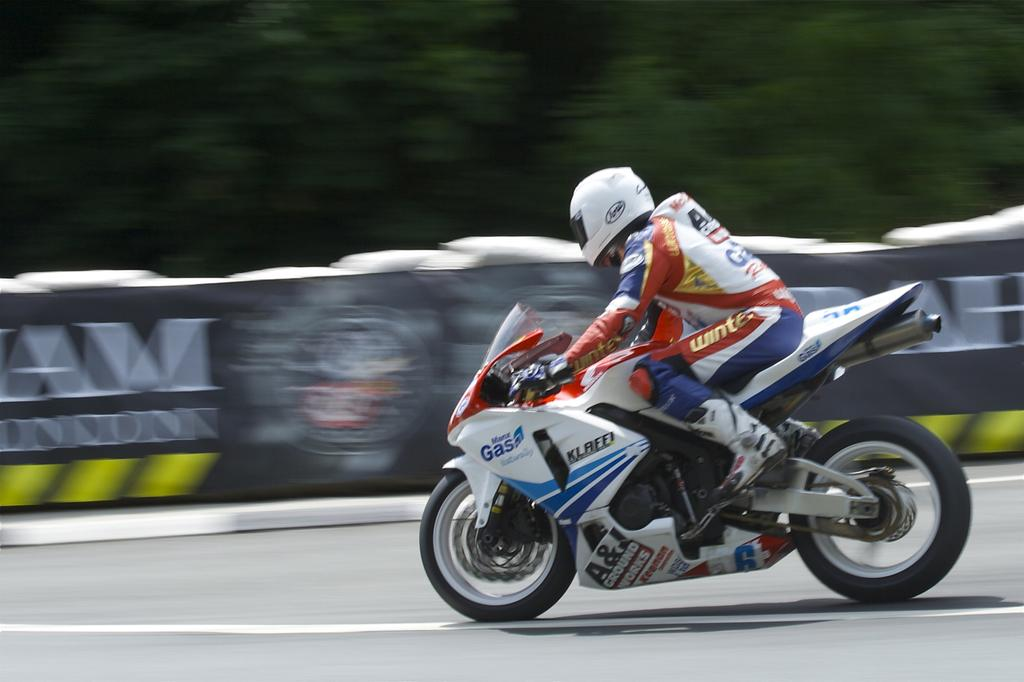What is the person in the image doing? The person is riding a motorcycle in the image. What protective gear is the person wearing? The person is wearing a helmet and gloves. What is the person riding on? The person is riding a motorcycle. Where is the motorcycle located? The motorcycle is on the road. What can be seen in the background of the image? The background of the image is blurry, and there are objects like banners visible. What type of cord is being used to decorate the holiday tree in the image? There is no holiday tree or cord present in the image; it features a person riding a motorcycle on the road. Can you tell me the name of the person's father in the image? There is no information about the person's father or any family members in the image. 